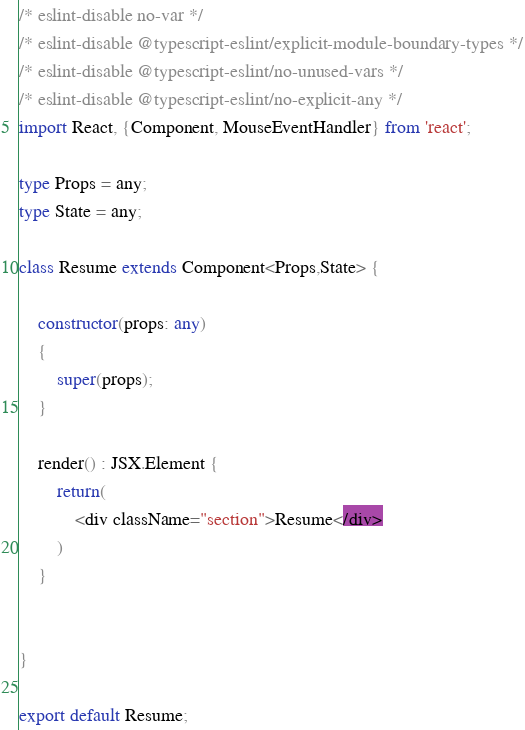Convert code to text. <code><loc_0><loc_0><loc_500><loc_500><_TypeScript_>/* eslint-disable no-var */
/* eslint-disable @typescript-eslint/explicit-module-boundary-types */
/* eslint-disable @typescript-eslint/no-unused-vars */
/* eslint-disable @typescript-eslint/no-explicit-any */
import React, {Component, MouseEventHandler} from 'react';

type Props = any;
type State = any;

class Resume extends Component<Props,State> {

    constructor(props: any)
    {
        super(props);
    }

    render() : JSX.Element {
        return(
            <div className="section">Resume</div>
        )
    }


}

export default Resume;</code> 